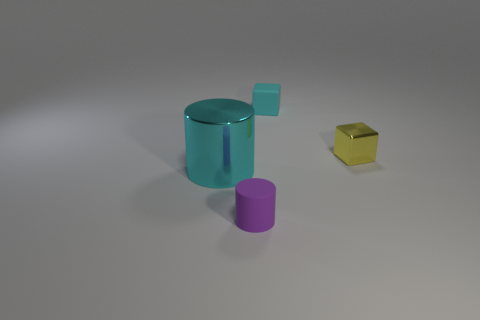Subtract all cyan cubes. How many cubes are left? 1 Add 2 rubber cylinders. How many objects exist? 6 Subtract all purple cylinders. Subtract all brown cubes. How many cylinders are left? 1 Subtract all brown cylinders. How many red cubes are left? 0 Subtract all green blocks. Subtract all small blocks. How many objects are left? 2 Add 2 cyan metallic things. How many cyan metallic things are left? 3 Add 3 rubber cubes. How many rubber cubes exist? 4 Subtract 0 brown cylinders. How many objects are left? 4 